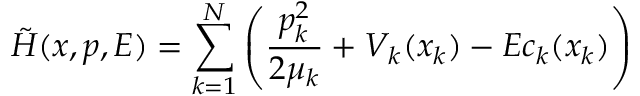Convert formula to latex. <formula><loc_0><loc_0><loc_500><loc_500>\tilde { H } ( x , p , E ) = \sum _ { k = 1 } ^ { N } \left ( \frac { p _ { k } ^ { 2 } } { 2 \mu _ { k } } + V _ { k } ( x _ { k } ) - E c _ { k } ( x _ { k } ) \right )</formula> 